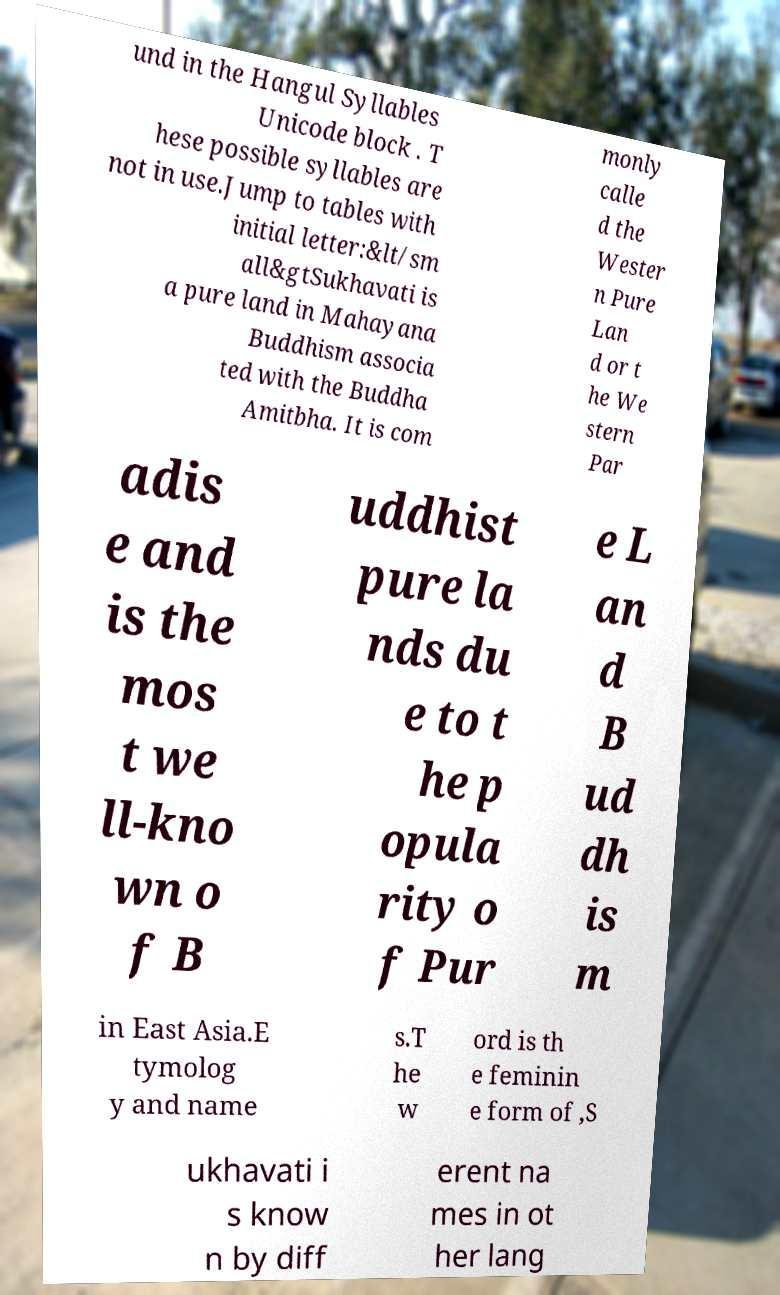What messages or text are displayed in this image? I need them in a readable, typed format. und in the Hangul Syllables Unicode block . T hese possible syllables are not in use.Jump to tables with initial letter:&lt/sm all&gtSukhavati is a pure land in Mahayana Buddhism associa ted with the Buddha Amitbha. It is com monly calle d the Wester n Pure Lan d or t he We stern Par adis e and is the mos t we ll-kno wn o f B uddhist pure la nds du e to t he p opula rity o f Pur e L an d B ud dh is m in East Asia.E tymolog y and name s.T he w ord is th e feminin e form of ,S ukhavati i s know n by diff erent na mes in ot her lang 